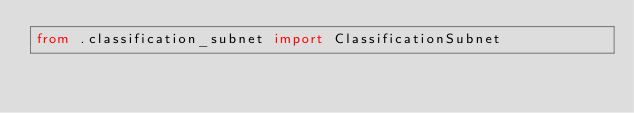<code> <loc_0><loc_0><loc_500><loc_500><_Python_>from .classification_subnet import ClassificationSubnet</code> 